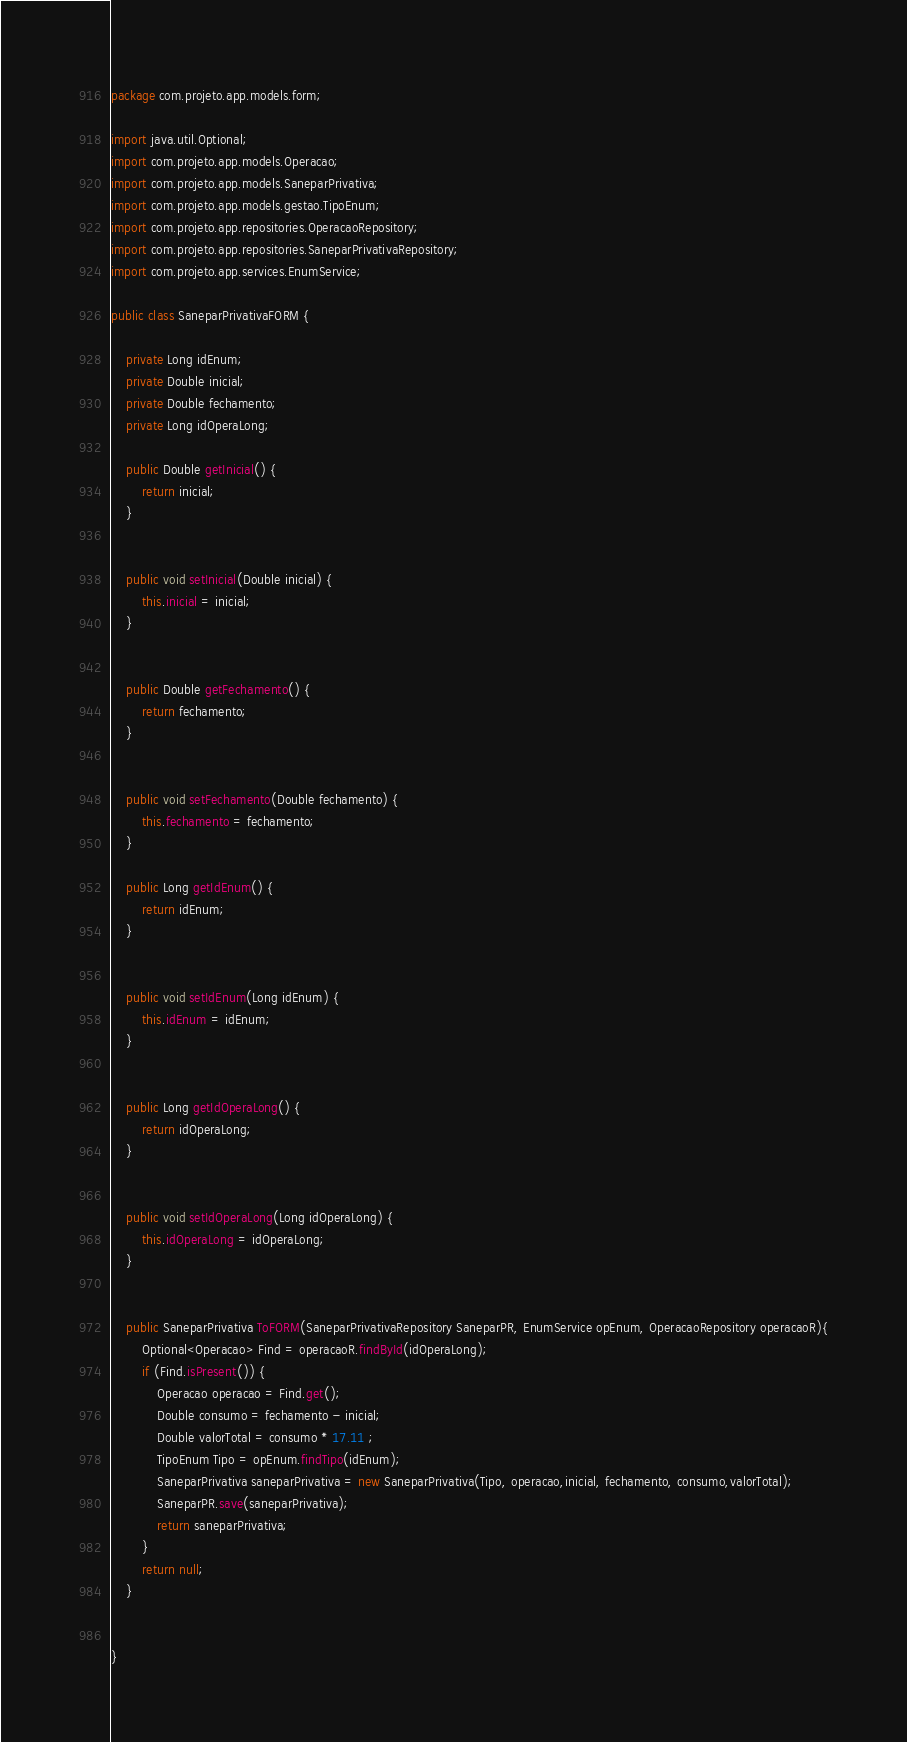<code> <loc_0><loc_0><loc_500><loc_500><_Java_>package com.projeto.app.models.form;

import java.util.Optional;
import com.projeto.app.models.Operacao;
import com.projeto.app.models.SaneparPrivativa;
import com.projeto.app.models.gestao.TipoEnum;
import com.projeto.app.repositories.OperacaoRepository;
import com.projeto.app.repositories.SaneparPrivativaRepository;
import com.projeto.app.services.EnumService;

public class SaneparPrivativaFORM {

    private Long idEnum;
    private Double inicial;
    private Double fechamento;
    private Long idOperaLong;
   
    public Double getInicial() {
        return inicial;
    }

   
    public void setInicial(Double inicial) {
        this.inicial = inicial;
    }

    
    public Double getFechamento() {
        return fechamento;
    }

    
    public void setFechamento(Double fechamento) {
        this.fechamento = fechamento;
    }

    public Long getIdEnum() {
        return idEnum;
    }

    
    public void setIdEnum(Long idEnum) {
        this.idEnum = idEnum;
    }

    
    public Long getIdOperaLong() {
        return idOperaLong;
    }


    public void setIdOperaLong(Long idOperaLong) {
        this.idOperaLong = idOperaLong;
    }


    public SaneparPrivativa ToFORM(SaneparPrivativaRepository SaneparPR, EnumService opEnum, OperacaoRepository operacaoR){
        Optional<Operacao> Find = operacaoR.findById(idOperaLong);
        if (Find.isPresent()) {
            Operacao operacao = Find.get();
            Double consumo = fechamento - inicial;
            Double valorTotal = consumo * 17.11 ;
            TipoEnum Tipo = opEnum.findTipo(idEnum);
            SaneparPrivativa saneparPrivativa = new SaneparPrivativa(Tipo, operacao,inicial, fechamento, consumo,valorTotal);
            SaneparPR.save(saneparPrivativa);
            return saneparPrivativa;  
        }
        return null;
    }


}</code> 